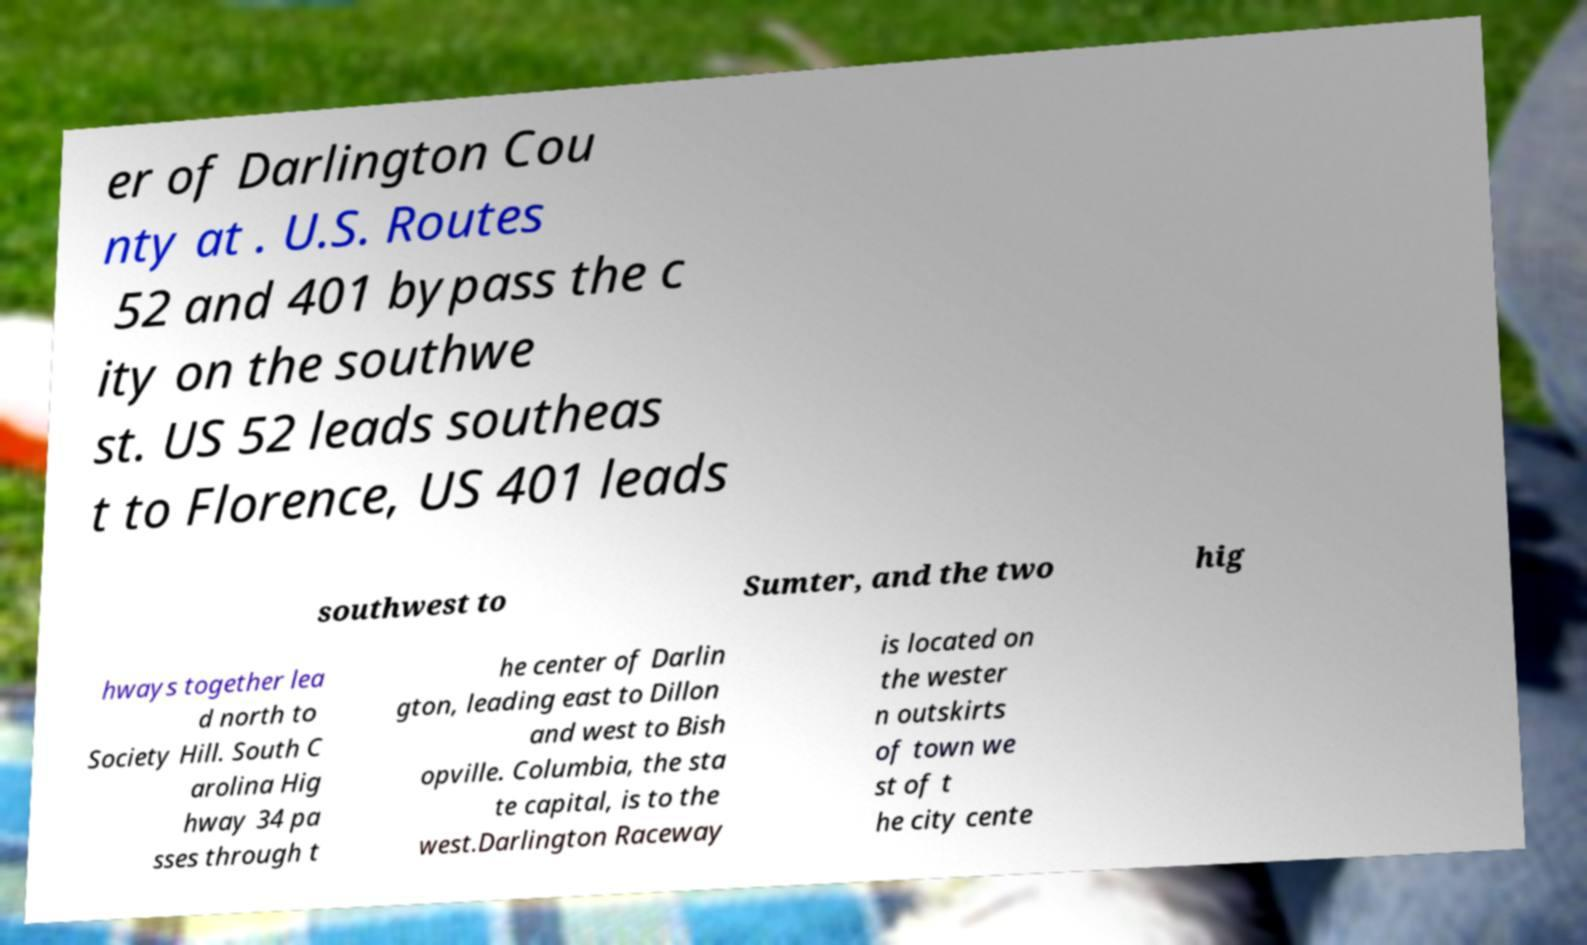Can you read and provide the text displayed in the image?This photo seems to have some interesting text. Can you extract and type it out for me? er of Darlington Cou nty at . U.S. Routes 52 and 401 bypass the c ity on the southwe st. US 52 leads southeas t to Florence, US 401 leads southwest to Sumter, and the two hig hways together lea d north to Society Hill. South C arolina Hig hway 34 pa sses through t he center of Darlin gton, leading east to Dillon and west to Bish opville. Columbia, the sta te capital, is to the west.Darlington Raceway is located on the wester n outskirts of town we st of t he city cente 